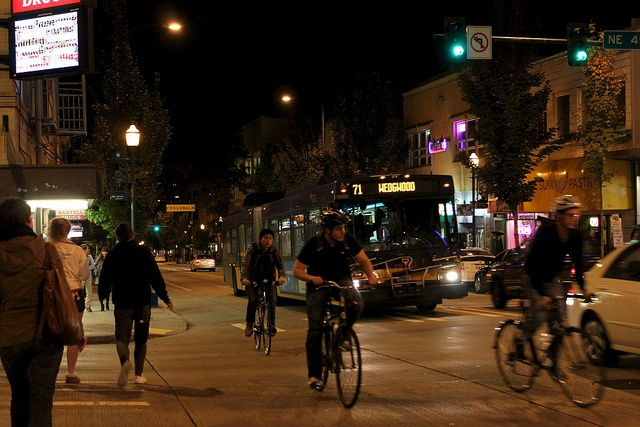Describe the objects in this image and their specific colors. I can see bus in olive, black, maroon, and gray tones, people in olive, black, maroon, and gray tones, bicycle in olive, black, maroon, and brown tones, people in olive, black, maroon, and brown tones, and people in olive, black, maroon, and brown tones in this image. 